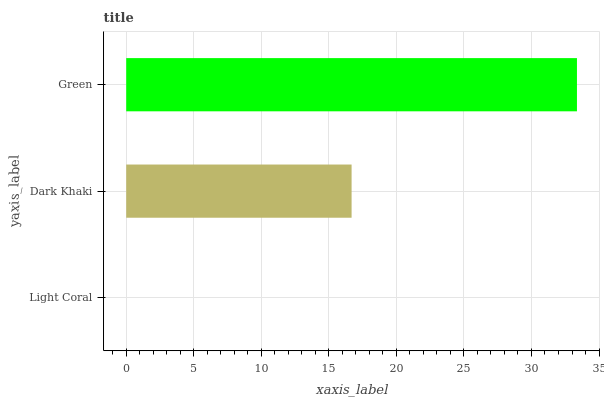Is Light Coral the minimum?
Answer yes or no. Yes. Is Green the maximum?
Answer yes or no. Yes. Is Dark Khaki the minimum?
Answer yes or no. No. Is Dark Khaki the maximum?
Answer yes or no. No. Is Dark Khaki greater than Light Coral?
Answer yes or no. Yes. Is Light Coral less than Dark Khaki?
Answer yes or no. Yes. Is Light Coral greater than Dark Khaki?
Answer yes or no. No. Is Dark Khaki less than Light Coral?
Answer yes or no. No. Is Dark Khaki the high median?
Answer yes or no. Yes. Is Dark Khaki the low median?
Answer yes or no. Yes. Is Light Coral the high median?
Answer yes or no. No. Is Green the low median?
Answer yes or no. No. 